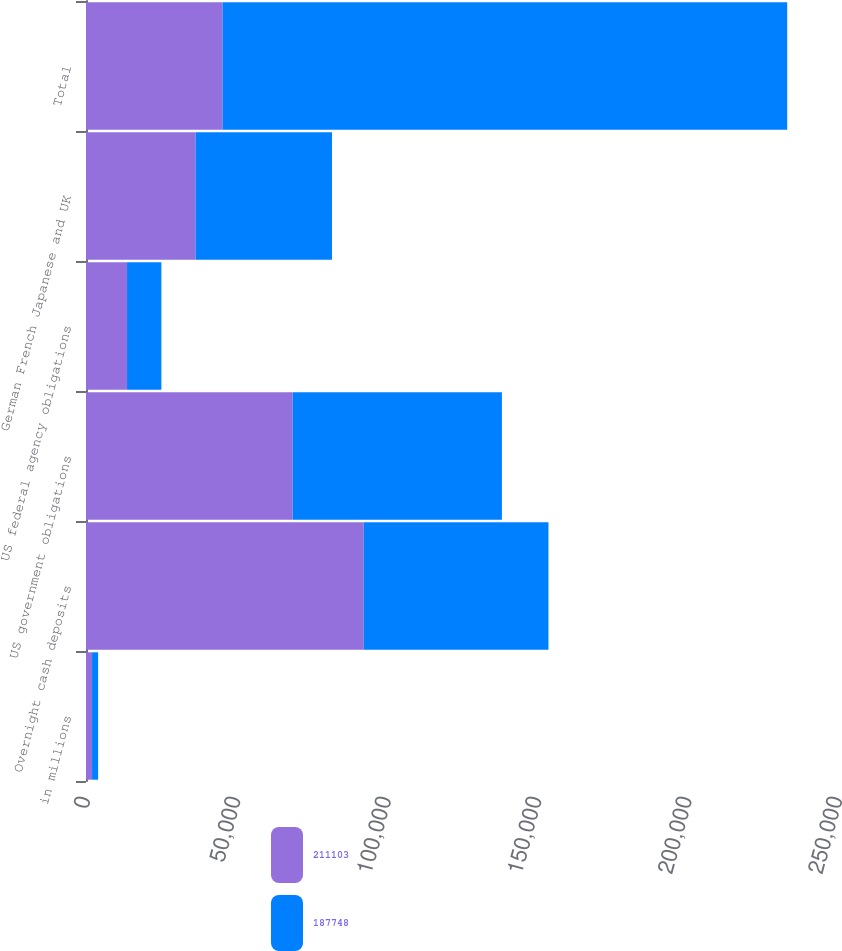<chart> <loc_0><loc_0><loc_500><loc_500><stacked_bar_chart><ecel><fcel>in millions<fcel>Overnight cash deposits<fcel>US government obligations<fcel>US federal agency obligations<fcel>German French Japanese and UK<fcel>Total<nl><fcel>211103<fcel>2016<fcel>92336<fcel>68708<fcel>13645<fcel>36414<fcel>45366<nl><fcel>187748<fcel>2015<fcel>61407<fcel>69562<fcel>11413<fcel>45366<fcel>187748<nl></chart> 